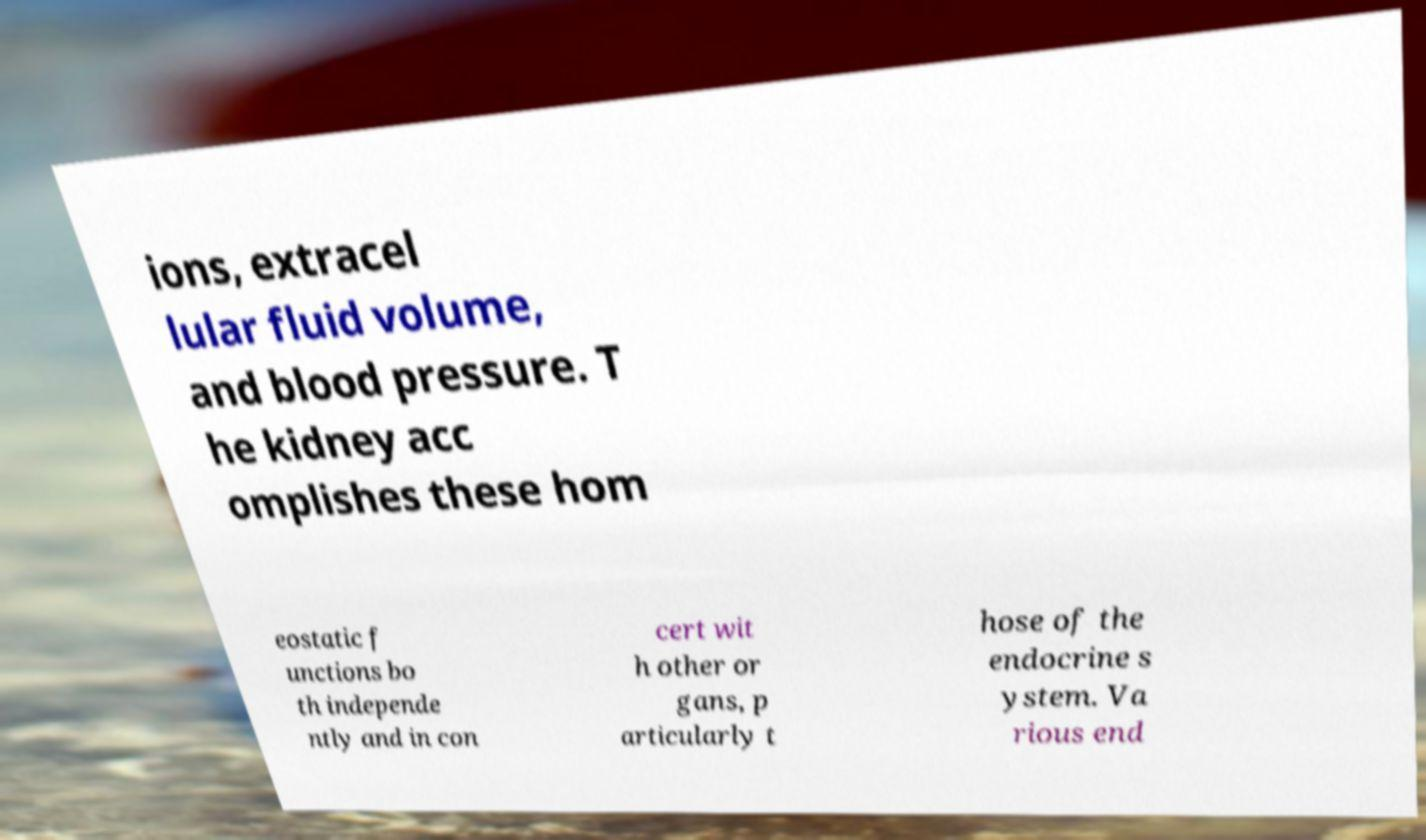I need the written content from this picture converted into text. Can you do that? ions, extracel lular fluid volume, and blood pressure. T he kidney acc omplishes these hom eostatic f unctions bo th independe ntly and in con cert wit h other or gans, p articularly t hose of the endocrine s ystem. Va rious end 